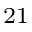Convert formula to latex. <formula><loc_0><loc_0><loc_500><loc_500>_ { 2 1 }</formula> 